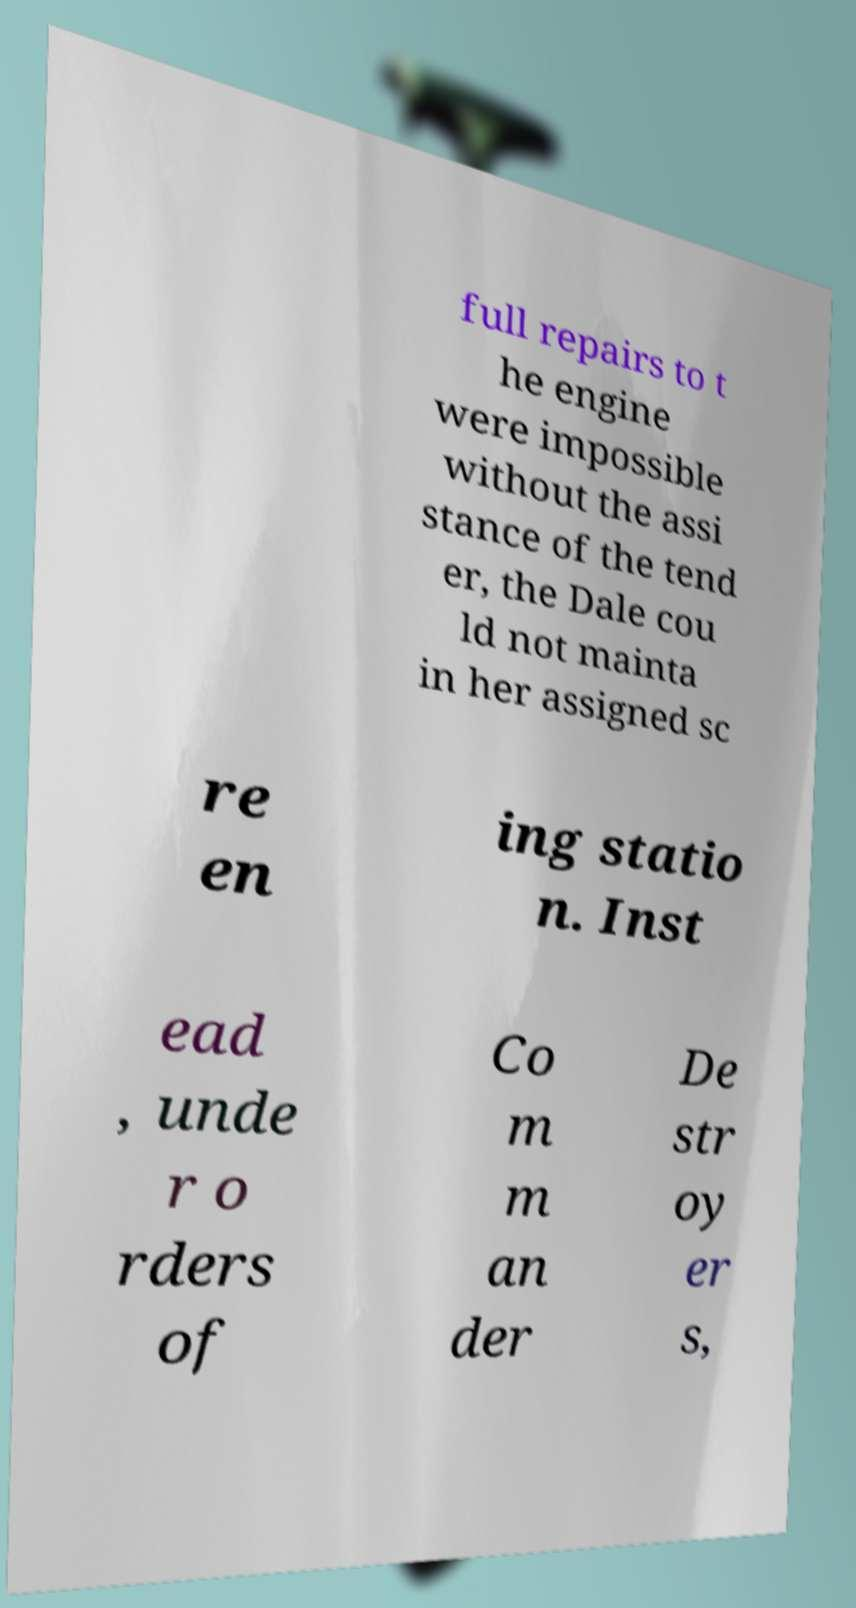For documentation purposes, I need the text within this image transcribed. Could you provide that? full repairs to t he engine were impossible without the assi stance of the tend er, the Dale cou ld not mainta in her assigned sc re en ing statio n. Inst ead , unde r o rders of Co m m an der De str oy er s, 